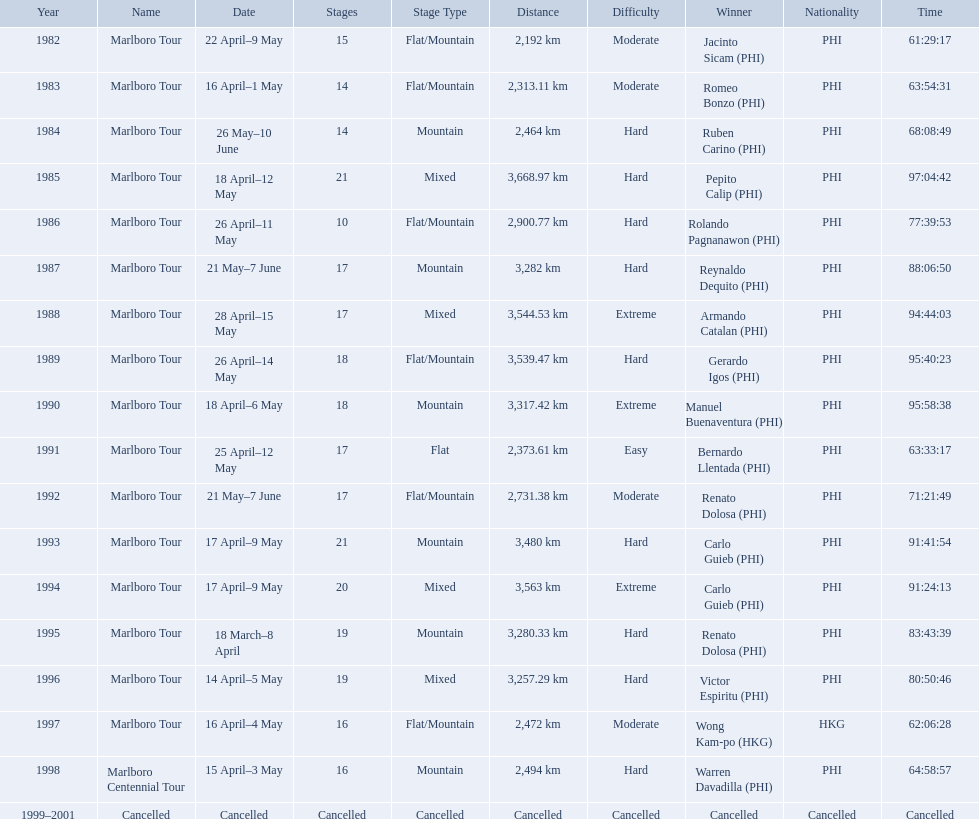What are the distances travelled on the tour? 2,192 km, 2,313.11 km, 2,464 km, 3,668.97 km, 2,900.77 km, 3,282 km, 3,544.53 km, 3,539.47 km, 3,317.42 km, 2,373.61 km, 2,731.38 km, 3,480 km, 3,563 km, 3,280.33 km, 3,257.29 km, 2,472 km, 2,494 km. Which of these are the largest? 3,668.97 km. How far did the marlboro tour travel each year? 2,192 km, 2,313.11 km, 2,464 km, 3,668.97 km, 2,900.77 km, 3,282 km, 3,544.53 km, 3,539.47 km, 3,317.42 km, 2,373.61 km, 2,731.38 km, 3,480 km, 3,563 km, 3,280.33 km, 3,257.29 km, 2,472 km, 2,494 km, Cancelled. In what year did they travel the furthest? 1985. How far did they travel that year? 3,668.97 km. 